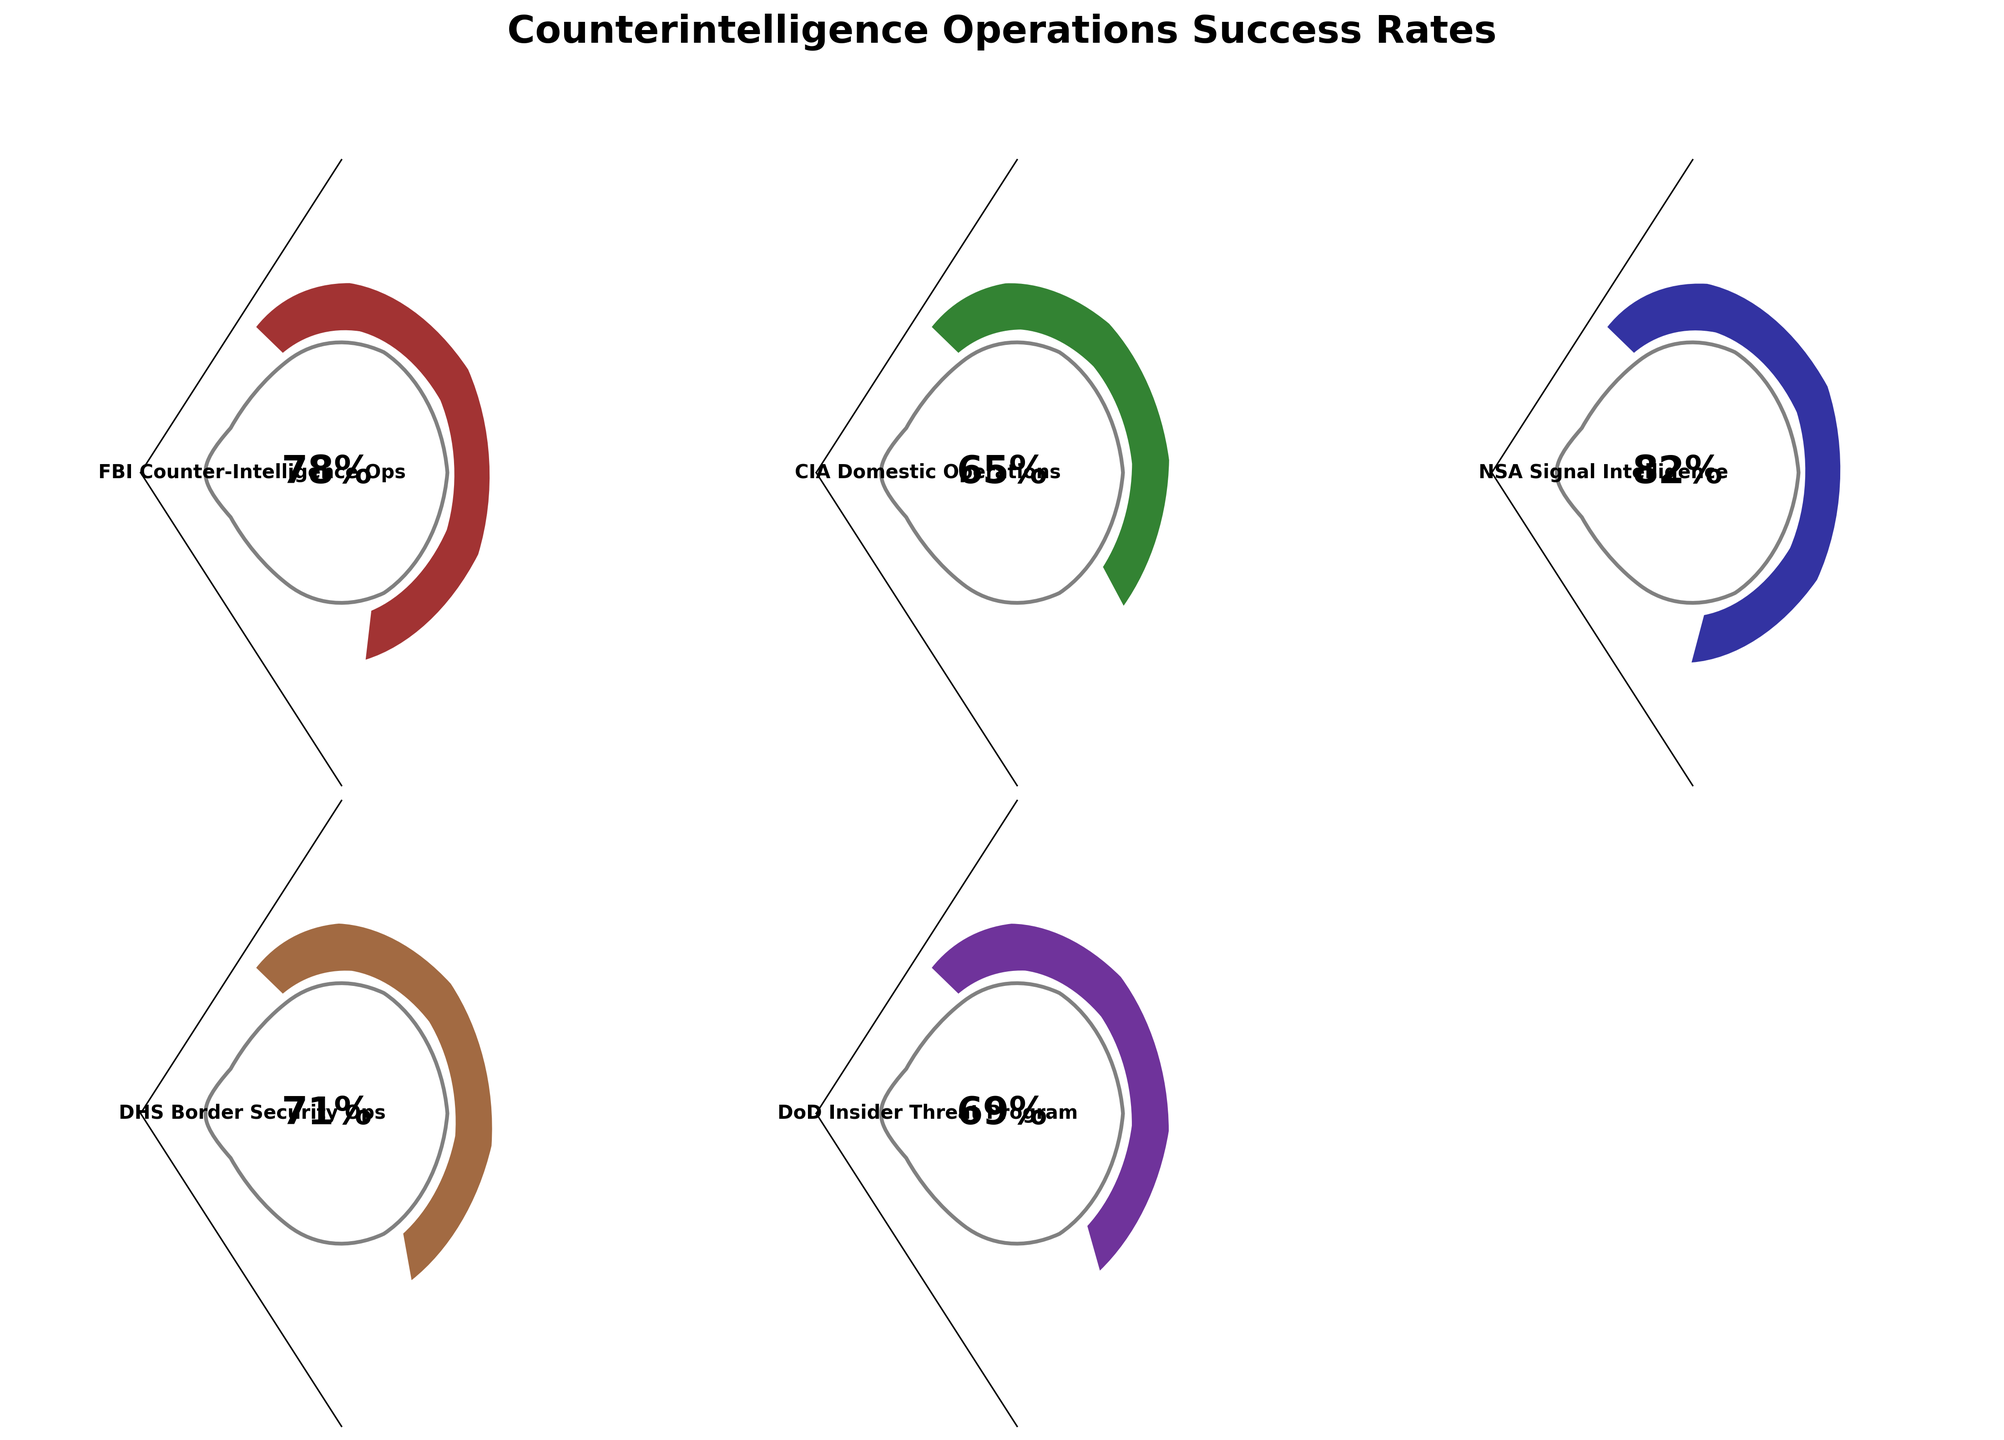Which counterintelligence operation has the highest success rate? By observing the figures, the NSA Signal Intelligence has the highest success rate, indicated by a gauge filled to 82%.
Answer: NSA Signal Intelligence Which operation has the second-lowest success rate? By looking at the percentages, the DHS Border Security Ops at 71% has the second-lowest rate, with the DoD Insider Threat Program at 69% being the lowest.
Answer: DHS Border Security Ops What is the average success rate of all the operations? Sum the success rates of all operations (78 + 65 + 82 + 71 + 69), which equals 365, then divide by the number of operations, which is 5: 365 / 5 = 73%.
Answer: 73% What is the difference in success rate between the FBI Counter-Intelligence Ops and the CIA Domestic Operations? The success rates are 78% for FBI Counter-Intelligence Ops and 65% for CIA Domestic Operations. The difference is calculated as 78 - 65 = 13%.
Answer: 13% Which operation(s) have a success rate greater than 70%? By examining the success rates: FBI Counter-Intelligence Ops 78%, NSA Signal Intelligence 82%, and DHS Border Security Ops 71% are all greater than 70%.
Answer: FBI Counter-Intelligence Ops, NSA Signal Intelligence, DHS Border Security Ops What percentage of operations have a success rate below 70%? Out of the 5 operations, 2 (CIA Domestic Operations at 65% and DoD Insider Threat Program at 69%) have rates below 70%. The percentage is (2/5) * 100 = 40%.
Answer: 40% Which operation's success rate is closest to the average success rate of all operations? The average success rate across all operations is 73%. Comparing all rates, 71% (DHS Border Security Ops) is the closest to 73%.
Answer: DHS Border Security Ops If the rates of the FBI Counter-Intelligence Ops and DHS Border Security Ops were to swap, which would then be the second-highest success rate? Swapping 78% (FBI Counter-Intelligence Ops) with 71% (DHS Border Security Ops) results in FBI having 71%. The second-highest rate then would be the original NSA Signal Intelligence at 82%, leaving 78% (now for DHS) as the highest.
Answer: 78% (DHS) How many operations have a success rate of at least 65%? Examining the percentages, all operations except CIA Domestic Operations (65%) and DoD Insider Threat Program (69%) are at least 65%. Thus, the count is 4.
Answer: 4 